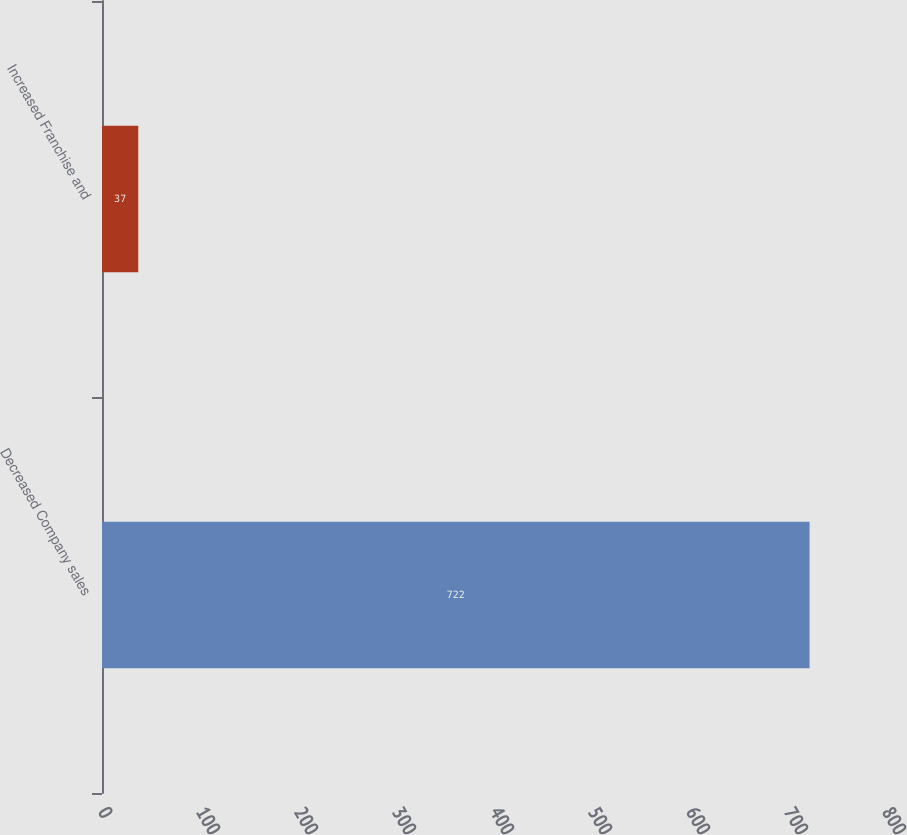Convert chart. <chart><loc_0><loc_0><loc_500><loc_500><bar_chart><fcel>Decreased Company sales<fcel>Increased Franchise and<nl><fcel>722<fcel>37<nl></chart> 